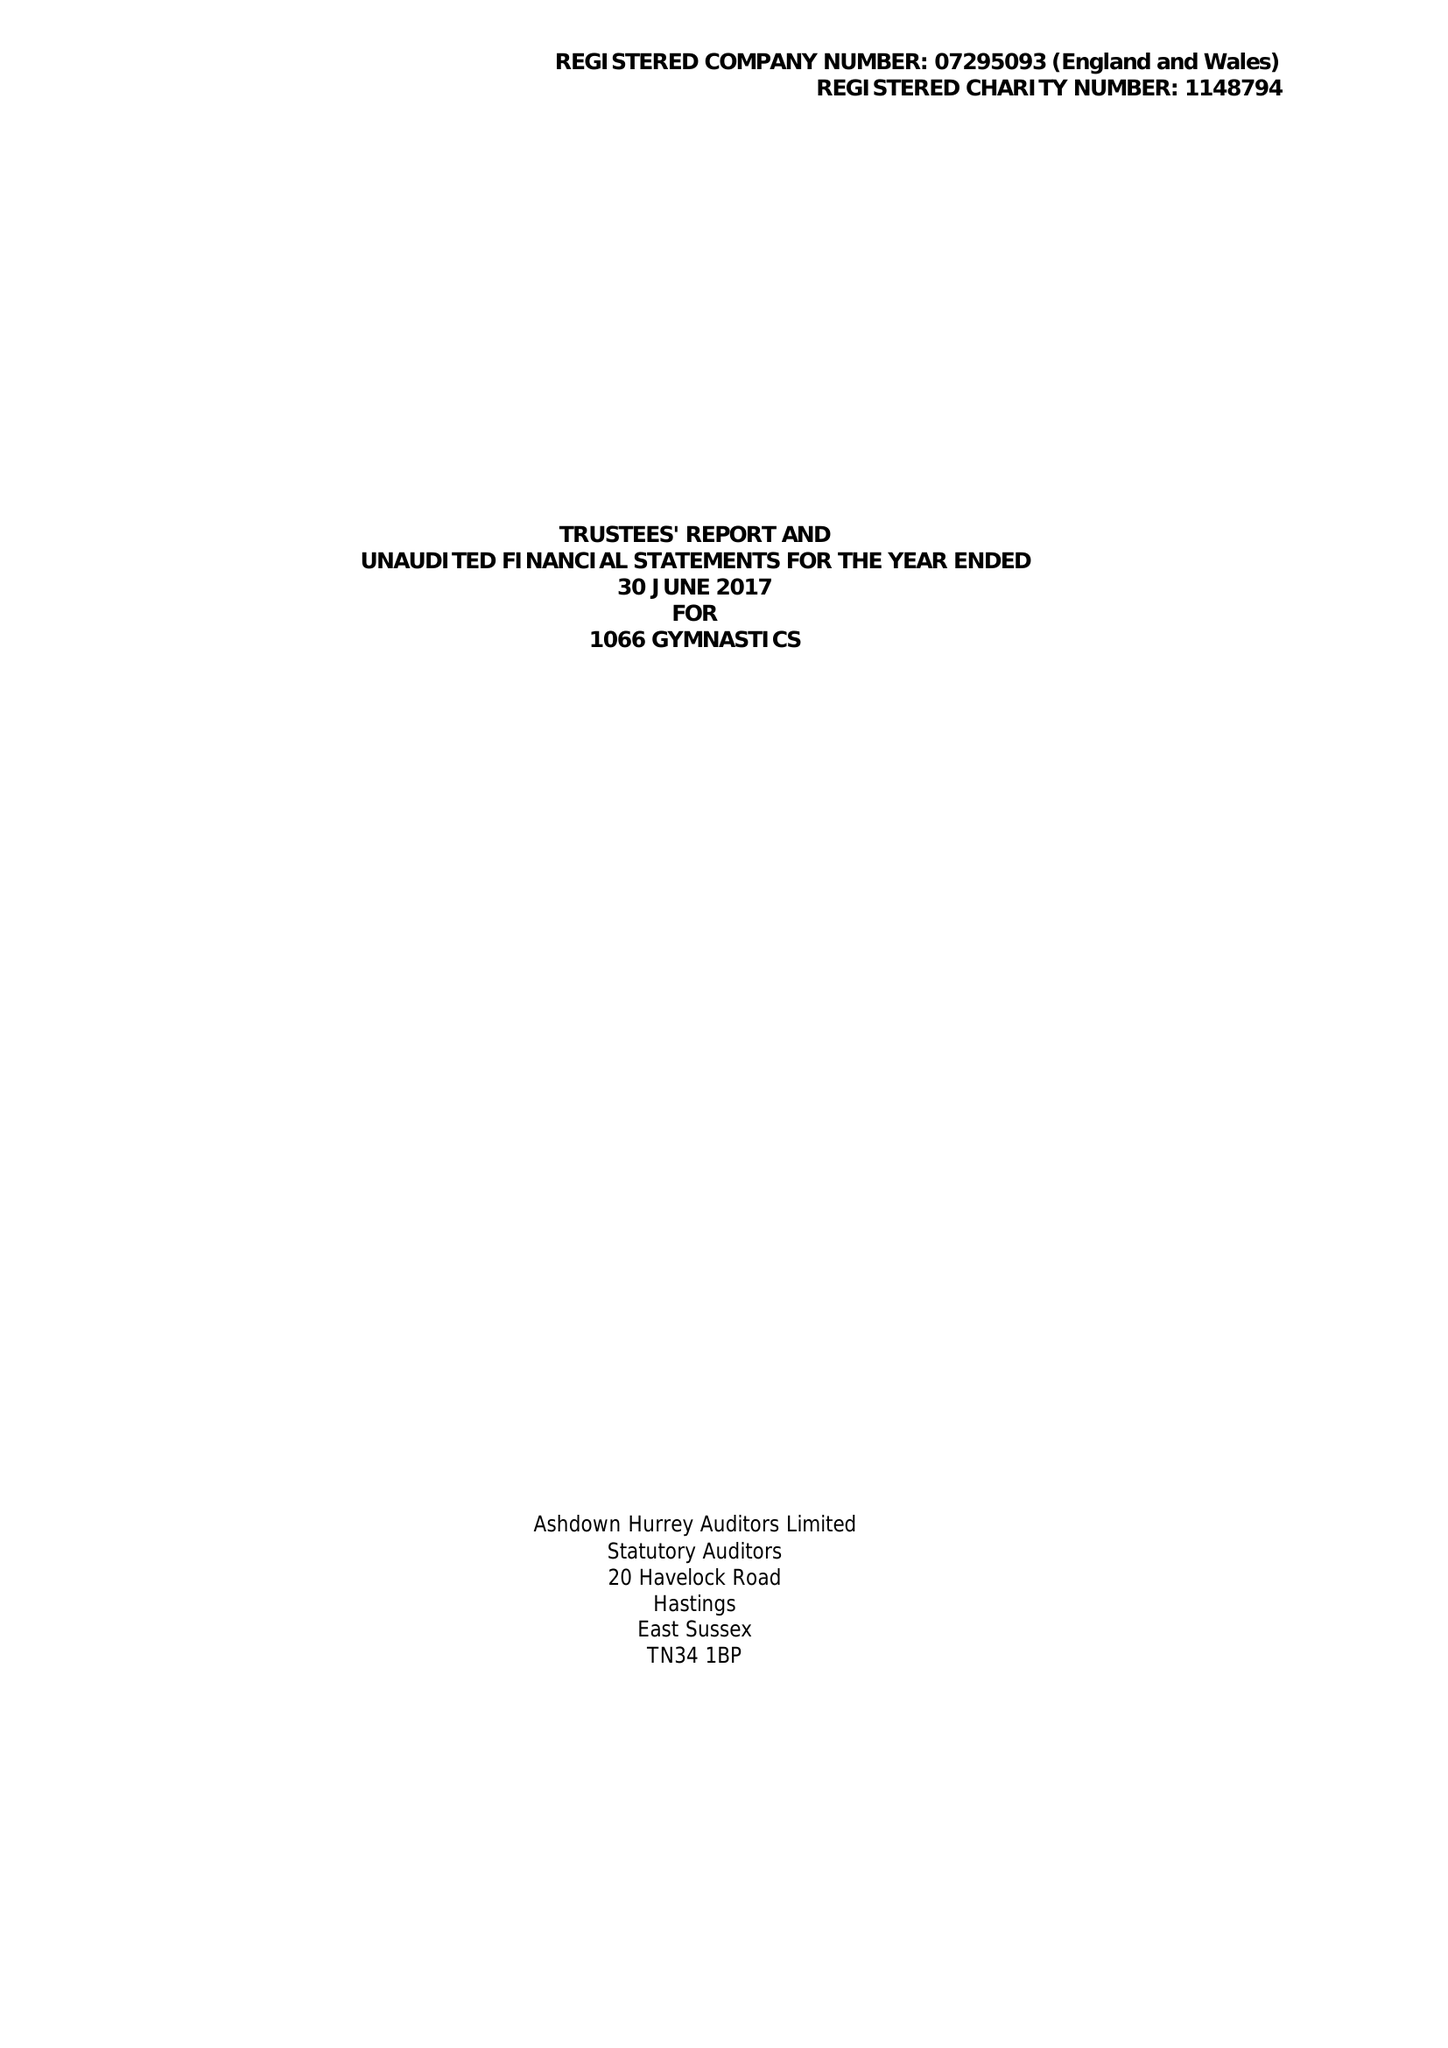What is the value for the charity_number?
Answer the question using a single word or phrase. 1148794 